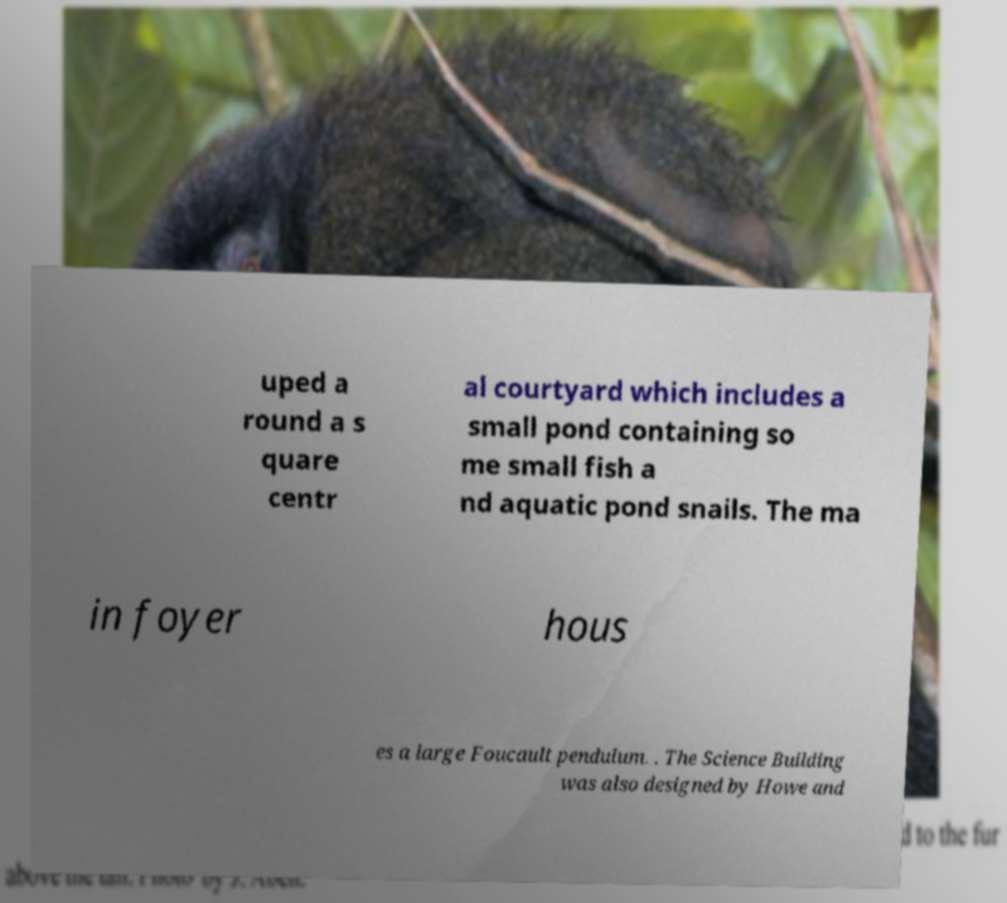Could you assist in decoding the text presented in this image and type it out clearly? uped a round a s quare centr al courtyard which includes a small pond containing so me small fish a nd aquatic pond snails. The ma in foyer hous es a large Foucault pendulum. . The Science Building was also designed by Howe and 